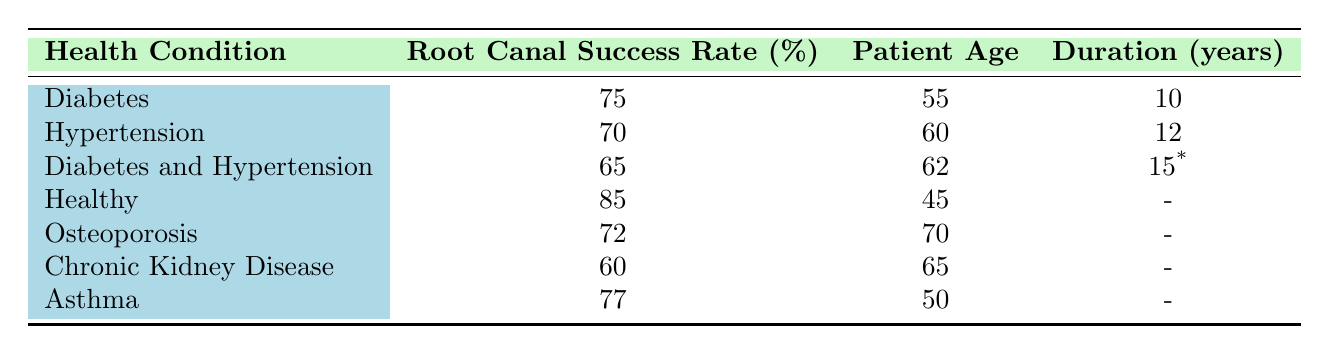What is the highest root canal success rate among the health conditions listed? The table shows the root canal success rates for various health conditions. By scanning through the "Root Canal Success Rate (%)" column, we see that "Healthy" has the highest rate of 85%.
Answer: 85 How does the root canal success rate of patients with diabetes compare to those without any health conditions? Comparing the "Root Canal Success Rate (%)" of "Diabetes" at 75% and "Healthy" at 85%, we find that patients with diabetes have a 10% lower success rate than those without health conditions.
Answer: 10% lower What is the root canal success rate for patients with chronic kidney disease? The table directly states that the root canal success rate for "Chronic Kidney Disease" is 60%.
Answer: 60% Is the duration of diabetes shorter than the duration of hypertension for any patient? We can compare the "Duration of Diabetes" (10 years) with the "Duration of Hypertension" (12 years) for the respective patients. Since 10 years is less than 12 years, the answer is yes, the duration of diabetes is shorter.
Answer: Yes What is the average root canal success rate for patients with any health condition? To find the average success rate, we add the success rates of all health conditions: (75 + 70 + 65 + 85 + 72 + 60 + 77) = 504. We have 7 conditions, so the average is 504 / 7 = 72. This is the average root canal success rate across all patients.
Answer: 72 Which health condition has the lowest root canal success rate based on this table? By looking at the "Root Canal Success Rate (%)" column, "Chronic Kidney Disease" has the lowest success rate at 60%.
Answer: 60% Do patients with both diabetes and hypertension have a higher or lower success rate compared to those with just one of the conditions? "Diabetes and Hypertension" has a success rate of 65%, which is lower than "Diabetes" at 75% and "Hypertension" at 70%. Thus, the combination yields a lower success rate.
Answer: Lower How many years of diabetes do patients diagnosed with it have on average? The only patient with diabetes has a duration of diabetes of 10 years, and the patient with "Diabetes and Hypertension" has it for 15 years. Thus, to find the average: (10 + 15) / 2 = 12.5 years.
Answer: 12.5 years 